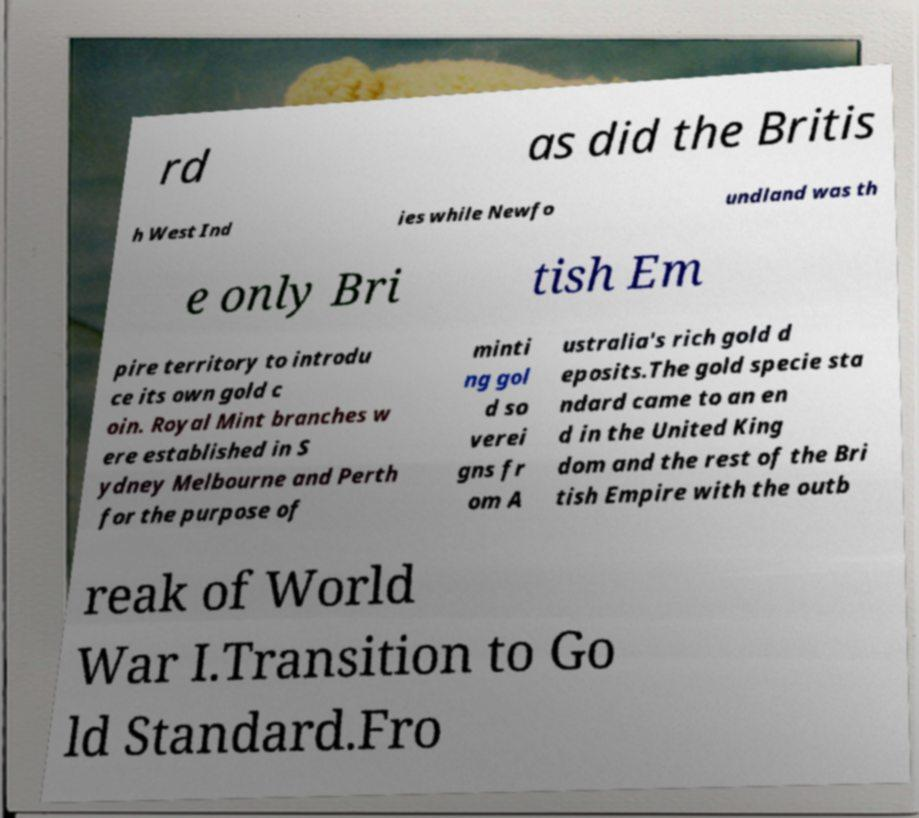What messages or text are displayed in this image? I need them in a readable, typed format. rd as did the Britis h West Ind ies while Newfo undland was th e only Bri tish Em pire territory to introdu ce its own gold c oin. Royal Mint branches w ere established in S ydney Melbourne and Perth for the purpose of minti ng gol d so verei gns fr om A ustralia's rich gold d eposits.The gold specie sta ndard came to an en d in the United King dom and the rest of the Bri tish Empire with the outb reak of World War I.Transition to Go ld Standard.Fro 